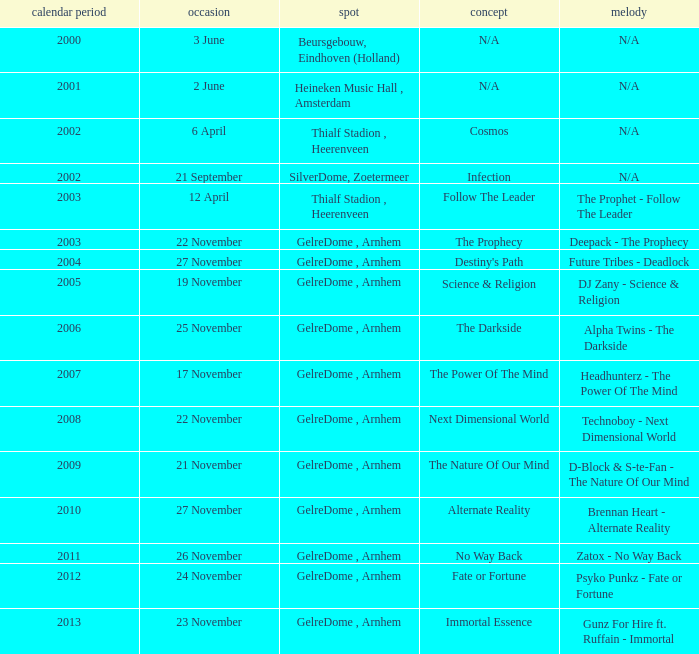What is the location in 2007? GelreDome , Arnhem. 